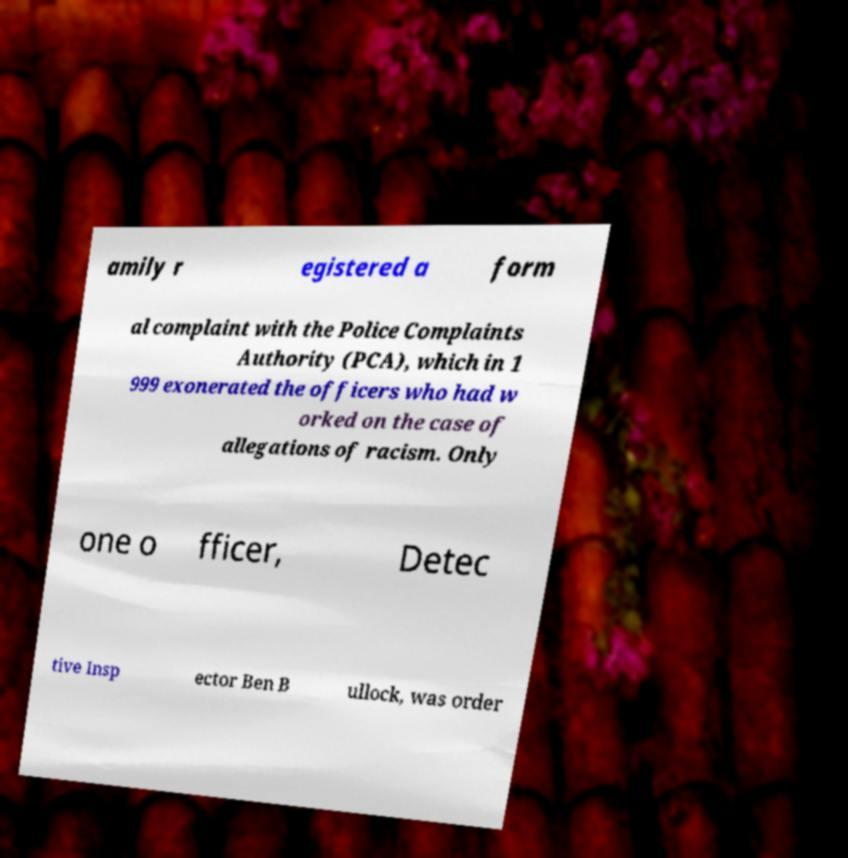Please read and relay the text visible in this image. What does it say? amily r egistered a form al complaint with the Police Complaints Authority (PCA), which in 1 999 exonerated the officers who had w orked on the case of allegations of racism. Only one o fficer, Detec tive Insp ector Ben B ullock, was order 